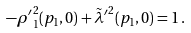Convert formula to latex. <formula><loc_0><loc_0><loc_500><loc_500>- \rho { ^ { \prime } } _ { 1 } ^ { 2 } ( p _ { 1 } , 0 ) + \tilde { \lambda } { ^ { \prime } } ^ { 2 } ( p _ { 1 } , 0 ) = 1 \, .</formula> 